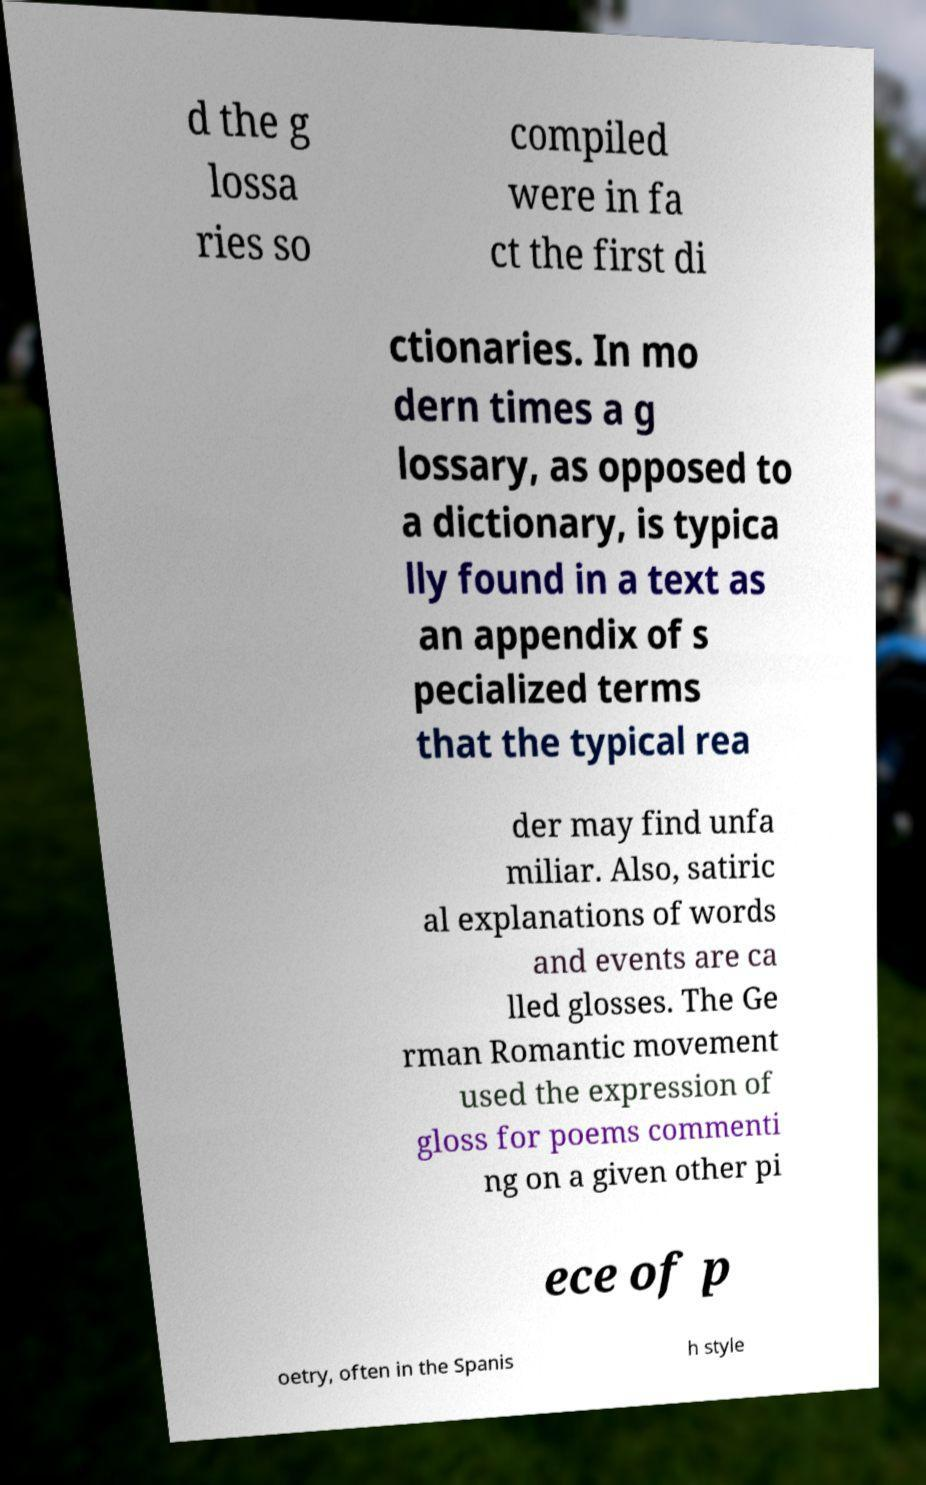Please identify and transcribe the text found in this image. d the g lossa ries so compiled were in fa ct the first di ctionaries. In mo dern times a g lossary, as opposed to a dictionary, is typica lly found in a text as an appendix of s pecialized terms that the typical rea der may find unfa miliar. Also, satiric al explanations of words and events are ca lled glosses. The Ge rman Romantic movement used the expression of gloss for poems commenti ng on a given other pi ece of p oetry, often in the Spanis h style 